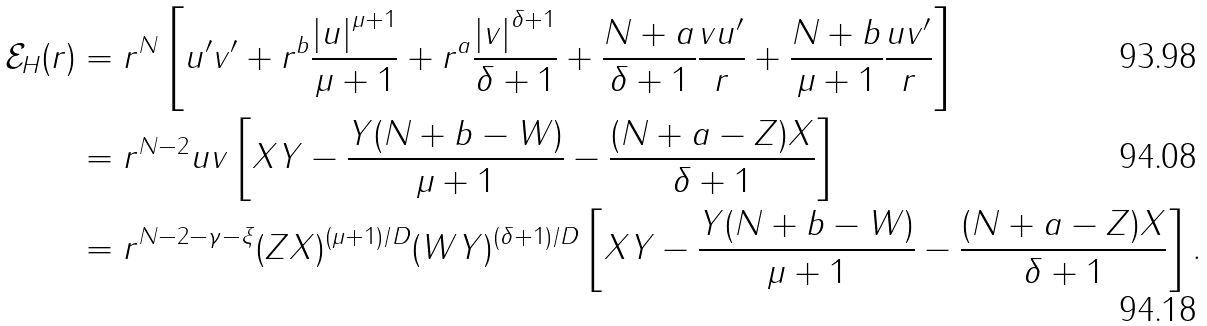<formula> <loc_0><loc_0><loc_500><loc_500>\mathcal { E } _ { H } ( r ) & = r ^ { N } \left [ u ^ { \prime } v ^ { \prime } + r ^ { b } \frac { \left | u \right | ^ { \mu + 1 } } { \mu + 1 } + r ^ { a } \frac { \left | v \right | ^ { \delta + 1 } } { \delta + 1 } + \frac { N + a } { \delta + 1 } \frac { v u ^ { \prime } } { r } + \frac { N + b } { \mu + 1 } \frac { u v ^ { \prime } } { r } \right ] \\ & = r ^ { N - 2 } u v \left [ X Y - \frac { Y ( N + b - W ) } { \mu + 1 } - \frac { ( N + a - Z ) X } { \delta + 1 } \right ] \\ & = r ^ { N - 2 - \gamma - \xi } ( Z X ) ^ { ( \mu + 1 ) / D } ( W Y ) ^ { ( \delta + 1 ) / D } \left [ X Y - \frac { Y ( N + b - W ) } { \mu + 1 } - \frac { ( N + a - Z ) X } { \delta + 1 } \right ] .</formula> 